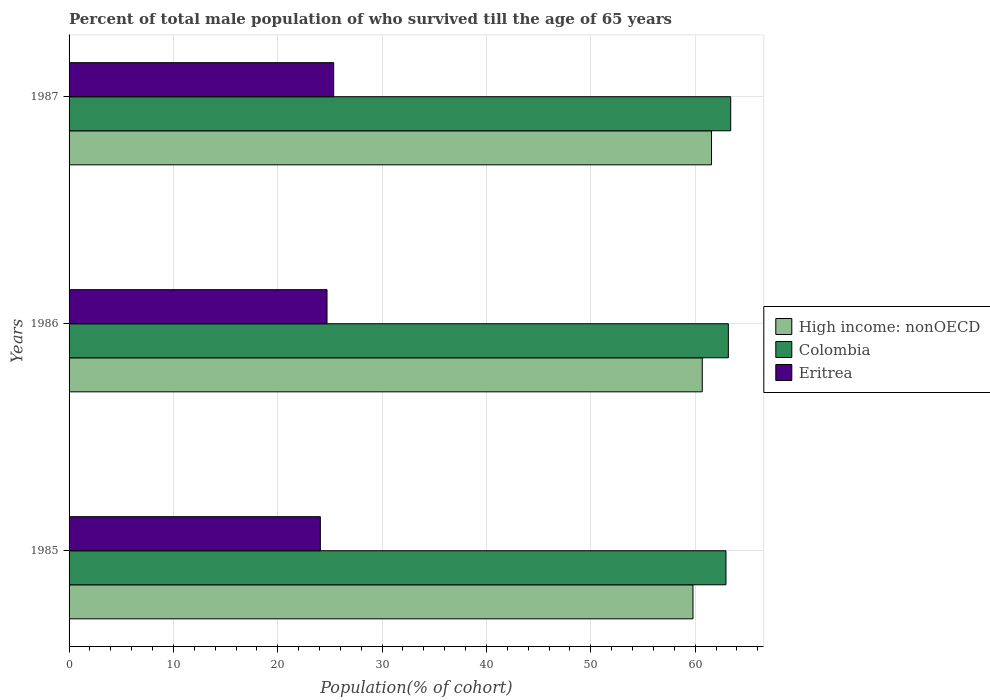How many groups of bars are there?
Keep it short and to the point. 3. Are the number of bars per tick equal to the number of legend labels?
Provide a short and direct response. Yes. How many bars are there on the 2nd tick from the bottom?
Keep it short and to the point. 3. In how many cases, is the number of bars for a given year not equal to the number of legend labels?
Your response must be concise. 0. What is the percentage of total male population who survived till the age of 65 years in Eritrea in 1987?
Make the answer very short. 25.36. Across all years, what is the maximum percentage of total male population who survived till the age of 65 years in High income: nonOECD?
Your answer should be compact. 61.57. Across all years, what is the minimum percentage of total male population who survived till the age of 65 years in High income: nonOECD?
Give a very brief answer. 59.79. In which year was the percentage of total male population who survived till the age of 65 years in High income: nonOECD maximum?
Provide a succinct answer. 1987. In which year was the percentage of total male population who survived till the age of 65 years in Eritrea minimum?
Your answer should be very brief. 1985. What is the total percentage of total male population who survived till the age of 65 years in High income: nonOECD in the graph?
Make the answer very short. 182.04. What is the difference between the percentage of total male population who survived till the age of 65 years in High income: nonOECD in 1986 and that in 1987?
Make the answer very short. -0.89. What is the difference between the percentage of total male population who survived till the age of 65 years in Eritrea in 1987 and the percentage of total male population who survived till the age of 65 years in High income: nonOECD in 1985?
Offer a terse response. -34.43. What is the average percentage of total male population who survived till the age of 65 years in Colombia per year?
Give a very brief answer. 63.18. In the year 1986, what is the difference between the percentage of total male population who survived till the age of 65 years in High income: nonOECD and percentage of total male population who survived till the age of 65 years in Eritrea?
Give a very brief answer. 35.96. In how many years, is the percentage of total male population who survived till the age of 65 years in Colombia greater than 16 %?
Your answer should be very brief. 3. What is the ratio of the percentage of total male population who survived till the age of 65 years in High income: nonOECD in 1985 to that in 1986?
Provide a short and direct response. 0.99. Is the percentage of total male population who survived till the age of 65 years in Colombia in 1986 less than that in 1987?
Give a very brief answer. Yes. Is the difference between the percentage of total male population who survived till the age of 65 years in High income: nonOECD in 1985 and 1986 greater than the difference between the percentage of total male population who survived till the age of 65 years in Eritrea in 1985 and 1986?
Make the answer very short. No. What is the difference between the highest and the second highest percentage of total male population who survived till the age of 65 years in Colombia?
Provide a succinct answer. 0.23. What is the difference between the highest and the lowest percentage of total male population who survived till the age of 65 years in High income: nonOECD?
Your response must be concise. 1.78. What does the 2nd bar from the top in 1987 represents?
Offer a terse response. Colombia. What does the 2nd bar from the bottom in 1985 represents?
Keep it short and to the point. Colombia. Is it the case that in every year, the sum of the percentage of total male population who survived till the age of 65 years in Colombia and percentage of total male population who survived till the age of 65 years in High income: nonOECD is greater than the percentage of total male population who survived till the age of 65 years in Eritrea?
Give a very brief answer. Yes. How many bars are there?
Keep it short and to the point. 9. How many years are there in the graph?
Ensure brevity in your answer.  3. Are the values on the major ticks of X-axis written in scientific E-notation?
Your response must be concise. No. Does the graph contain any zero values?
Your answer should be compact. No. Where does the legend appear in the graph?
Your answer should be very brief. Center right. How are the legend labels stacked?
Your response must be concise. Vertical. What is the title of the graph?
Your answer should be very brief. Percent of total male population of who survived till the age of 65 years. What is the label or title of the X-axis?
Keep it short and to the point. Population(% of cohort). What is the Population(% of cohort) in High income: nonOECD in 1985?
Offer a very short reply. 59.79. What is the Population(% of cohort) of Colombia in 1985?
Offer a very short reply. 62.95. What is the Population(% of cohort) of Eritrea in 1985?
Keep it short and to the point. 24.08. What is the Population(% of cohort) in High income: nonOECD in 1986?
Make the answer very short. 60.68. What is the Population(% of cohort) in Colombia in 1986?
Give a very brief answer. 63.18. What is the Population(% of cohort) in Eritrea in 1986?
Provide a succinct answer. 24.72. What is the Population(% of cohort) in High income: nonOECD in 1987?
Give a very brief answer. 61.57. What is the Population(% of cohort) of Colombia in 1987?
Offer a terse response. 63.41. What is the Population(% of cohort) of Eritrea in 1987?
Offer a very short reply. 25.36. Across all years, what is the maximum Population(% of cohort) of High income: nonOECD?
Give a very brief answer. 61.57. Across all years, what is the maximum Population(% of cohort) in Colombia?
Offer a terse response. 63.41. Across all years, what is the maximum Population(% of cohort) in Eritrea?
Your answer should be compact. 25.36. Across all years, what is the minimum Population(% of cohort) in High income: nonOECD?
Provide a succinct answer. 59.79. Across all years, what is the minimum Population(% of cohort) of Colombia?
Your answer should be compact. 62.95. Across all years, what is the minimum Population(% of cohort) in Eritrea?
Give a very brief answer. 24.08. What is the total Population(% of cohort) of High income: nonOECD in the graph?
Your response must be concise. 182.04. What is the total Population(% of cohort) of Colombia in the graph?
Provide a short and direct response. 189.54. What is the total Population(% of cohort) of Eritrea in the graph?
Keep it short and to the point. 74.16. What is the difference between the Population(% of cohort) of High income: nonOECD in 1985 and that in 1986?
Offer a very short reply. -0.89. What is the difference between the Population(% of cohort) of Colombia in 1985 and that in 1986?
Provide a succinct answer. -0.23. What is the difference between the Population(% of cohort) of Eritrea in 1985 and that in 1986?
Offer a very short reply. -0.64. What is the difference between the Population(% of cohort) in High income: nonOECD in 1985 and that in 1987?
Your answer should be compact. -1.78. What is the difference between the Population(% of cohort) in Colombia in 1985 and that in 1987?
Give a very brief answer. -0.45. What is the difference between the Population(% of cohort) in Eritrea in 1985 and that in 1987?
Keep it short and to the point. -1.28. What is the difference between the Population(% of cohort) in High income: nonOECD in 1986 and that in 1987?
Keep it short and to the point. -0.89. What is the difference between the Population(% of cohort) of Colombia in 1986 and that in 1987?
Offer a terse response. -0.23. What is the difference between the Population(% of cohort) in Eritrea in 1986 and that in 1987?
Provide a succinct answer. -0.64. What is the difference between the Population(% of cohort) in High income: nonOECD in 1985 and the Population(% of cohort) in Colombia in 1986?
Keep it short and to the point. -3.39. What is the difference between the Population(% of cohort) in High income: nonOECD in 1985 and the Population(% of cohort) in Eritrea in 1986?
Your response must be concise. 35.07. What is the difference between the Population(% of cohort) in Colombia in 1985 and the Population(% of cohort) in Eritrea in 1986?
Offer a very short reply. 38.23. What is the difference between the Population(% of cohort) in High income: nonOECD in 1985 and the Population(% of cohort) in Colombia in 1987?
Offer a very short reply. -3.62. What is the difference between the Population(% of cohort) of High income: nonOECD in 1985 and the Population(% of cohort) of Eritrea in 1987?
Offer a terse response. 34.43. What is the difference between the Population(% of cohort) in Colombia in 1985 and the Population(% of cohort) in Eritrea in 1987?
Your response must be concise. 37.59. What is the difference between the Population(% of cohort) in High income: nonOECD in 1986 and the Population(% of cohort) in Colombia in 1987?
Make the answer very short. -2.73. What is the difference between the Population(% of cohort) of High income: nonOECD in 1986 and the Population(% of cohort) of Eritrea in 1987?
Your answer should be very brief. 35.32. What is the difference between the Population(% of cohort) of Colombia in 1986 and the Population(% of cohort) of Eritrea in 1987?
Provide a succinct answer. 37.82. What is the average Population(% of cohort) of High income: nonOECD per year?
Ensure brevity in your answer.  60.68. What is the average Population(% of cohort) of Colombia per year?
Give a very brief answer. 63.18. What is the average Population(% of cohort) in Eritrea per year?
Your answer should be very brief. 24.72. In the year 1985, what is the difference between the Population(% of cohort) in High income: nonOECD and Population(% of cohort) in Colombia?
Ensure brevity in your answer.  -3.16. In the year 1985, what is the difference between the Population(% of cohort) of High income: nonOECD and Population(% of cohort) of Eritrea?
Ensure brevity in your answer.  35.71. In the year 1985, what is the difference between the Population(% of cohort) of Colombia and Population(% of cohort) of Eritrea?
Keep it short and to the point. 38.87. In the year 1986, what is the difference between the Population(% of cohort) in High income: nonOECD and Population(% of cohort) in Colombia?
Keep it short and to the point. -2.5. In the year 1986, what is the difference between the Population(% of cohort) of High income: nonOECD and Population(% of cohort) of Eritrea?
Offer a very short reply. 35.96. In the year 1986, what is the difference between the Population(% of cohort) of Colombia and Population(% of cohort) of Eritrea?
Keep it short and to the point. 38.46. In the year 1987, what is the difference between the Population(% of cohort) in High income: nonOECD and Population(% of cohort) in Colombia?
Make the answer very short. -1.84. In the year 1987, what is the difference between the Population(% of cohort) of High income: nonOECD and Population(% of cohort) of Eritrea?
Provide a succinct answer. 36.21. In the year 1987, what is the difference between the Population(% of cohort) of Colombia and Population(% of cohort) of Eritrea?
Your answer should be very brief. 38.05. What is the ratio of the Population(% of cohort) in Colombia in 1985 to that in 1986?
Your response must be concise. 1. What is the ratio of the Population(% of cohort) of Eritrea in 1985 to that in 1986?
Your answer should be compact. 0.97. What is the ratio of the Population(% of cohort) of High income: nonOECD in 1985 to that in 1987?
Ensure brevity in your answer.  0.97. What is the ratio of the Population(% of cohort) in Eritrea in 1985 to that in 1987?
Make the answer very short. 0.95. What is the ratio of the Population(% of cohort) of High income: nonOECD in 1986 to that in 1987?
Offer a very short reply. 0.99. What is the ratio of the Population(% of cohort) in Eritrea in 1986 to that in 1987?
Your response must be concise. 0.97. What is the difference between the highest and the second highest Population(% of cohort) in High income: nonOECD?
Provide a succinct answer. 0.89. What is the difference between the highest and the second highest Population(% of cohort) of Colombia?
Make the answer very short. 0.23. What is the difference between the highest and the second highest Population(% of cohort) of Eritrea?
Make the answer very short. 0.64. What is the difference between the highest and the lowest Population(% of cohort) in High income: nonOECD?
Your answer should be compact. 1.78. What is the difference between the highest and the lowest Population(% of cohort) in Colombia?
Give a very brief answer. 0.45. What is the difference between the highest and the lowest Population(% of cohort) of Eritrea?
Ensure brevity in your answer.  1.28. 